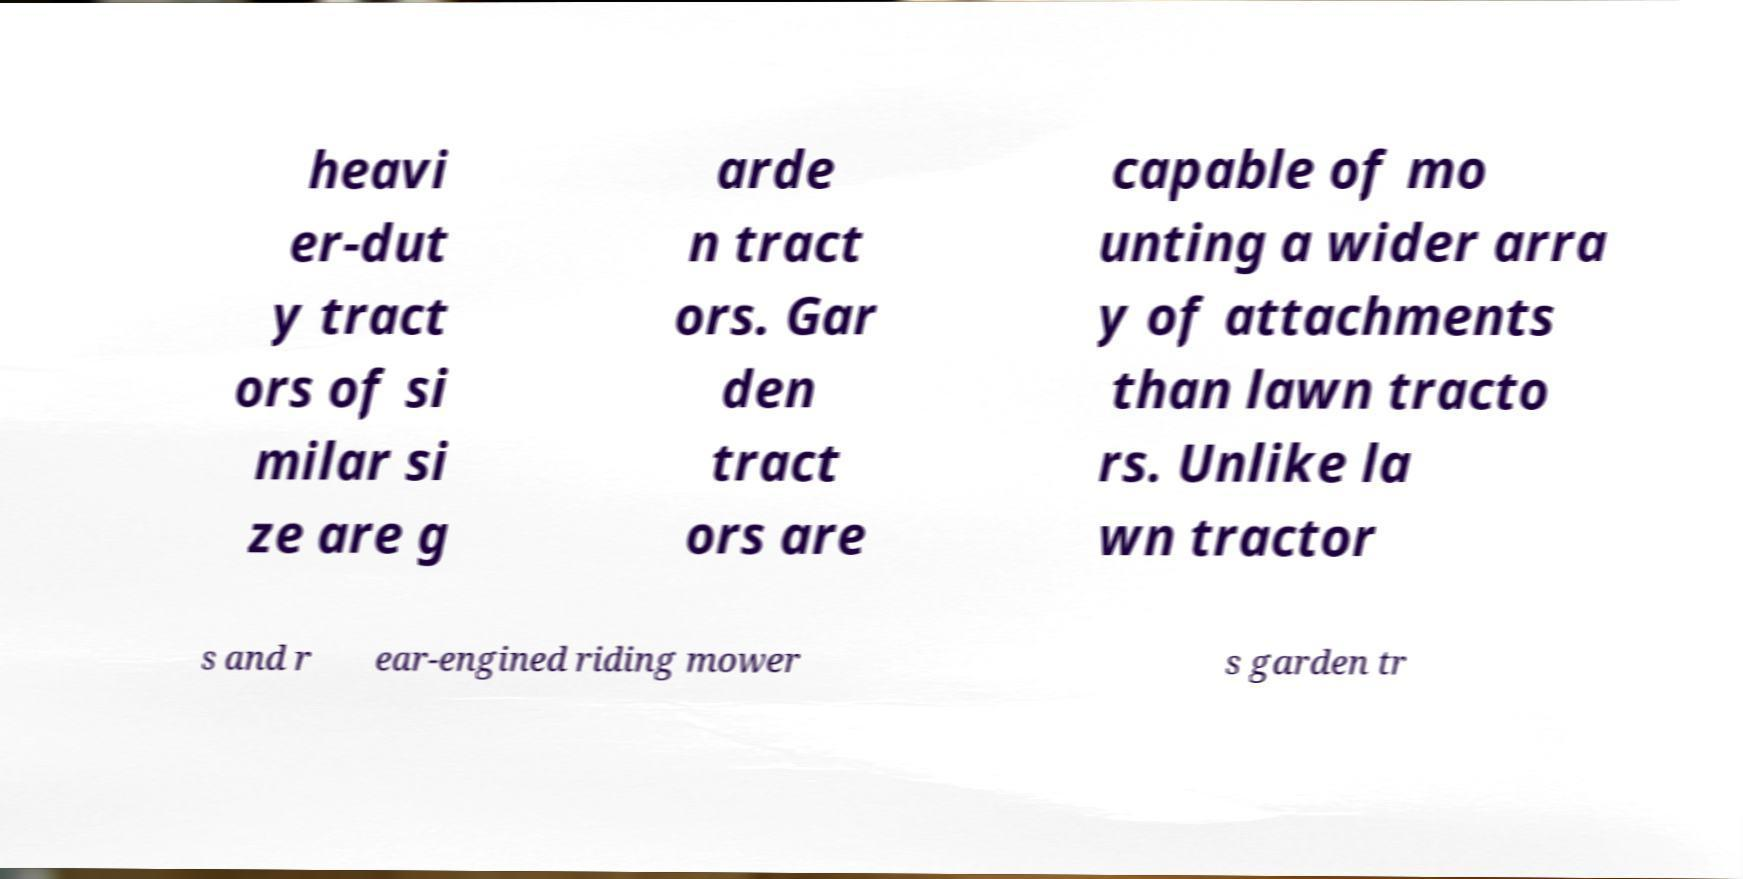What messages or text are displayed in this image? I need them in a readable, typed format. heavi er-dut y tract ors of si milar si ze are g arde n tract ors. Gar den tract ors are capable of mo unting a wider arra y of attachments than lawn tracto rs. Unlike la wn tractor s and r ear-engined riding mower s garden tr 